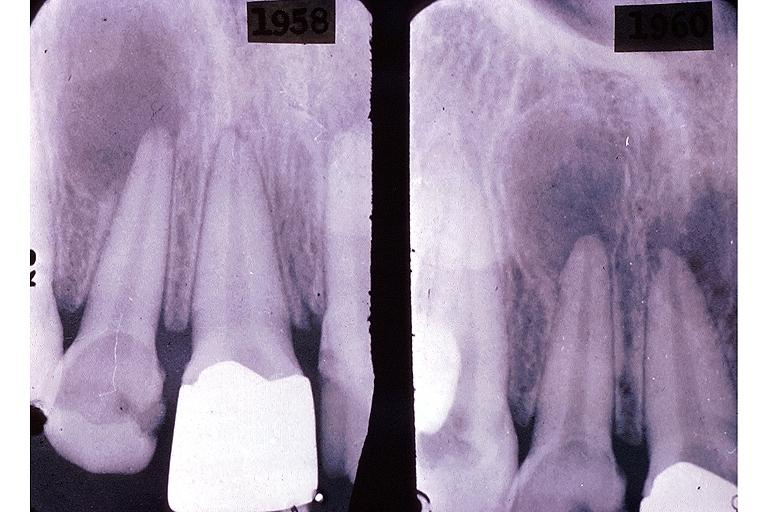does this image show periapical granuloma?
Answer the question using a single word or phrase. Yes 